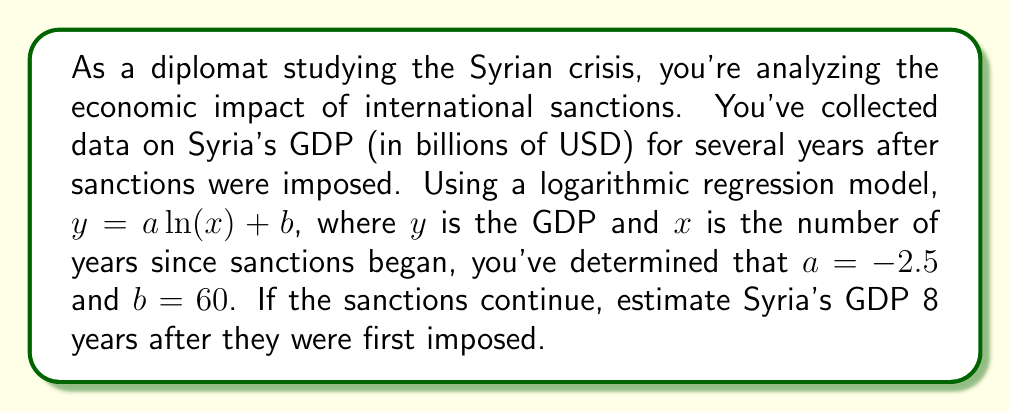What is the answer to this math problem? To solve this problem, we'll follow these steps:

1) We're given the logarithmic regression model:
   $y = a \ln(x) + b$

2) We know the following values:
   $a = -2.5$
   $b = 60$
   $x = 8$ (years since sanctions began)

3) Let's substitute these values into the equation:
   $y = -2.5 \ln(8) + 60$

4) Now we need to calculate $\ln(8)$:
   $\ln(8) \approx 2.0794$

5) Let's substitute this value:
   $y = -2.5(2.0794) + 60$

6) Now we can solve:
   $y = -5.1985 + 60$
   $y = 54.8015$

7) Since GDP is typically reported in whole numbers, we'll round to the nearest billion:
   $y \approx 55$

Therefore, 8 years after sanctions were imposed, Syria's estimated GDP would be approximately 55 billion USD.
Answer: $55$ billion USD 